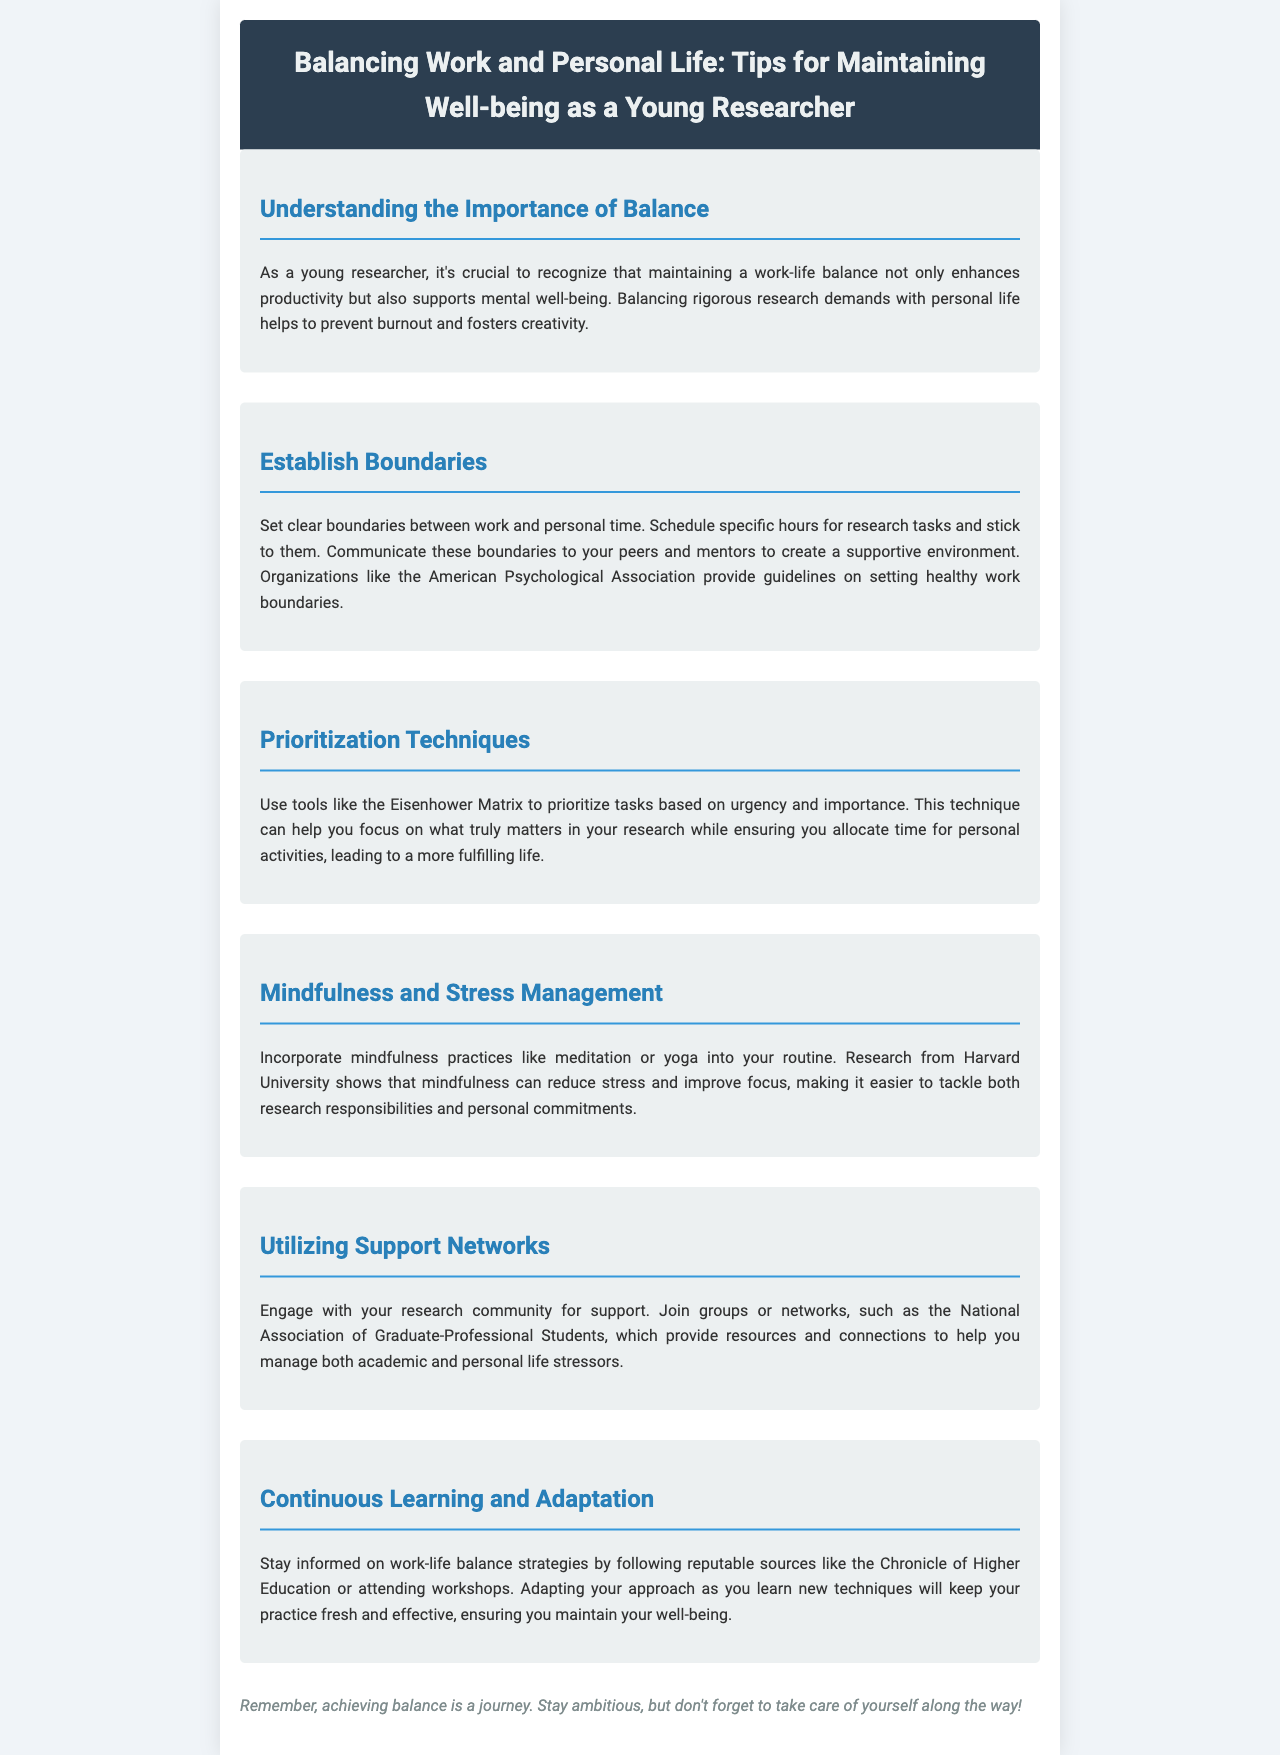What is the title of the newsletter? The title of the newsletter is stated at the top of the document.
Answer: Balancing Work and Personal Life: Tips for Maintaining Well-being as a Young Researcher What organization offers guidelines on setting healthy work boundaries? The document mentions an organization that provides guidelines for healthy work boundaries.
Answer: American Psychological Association What technique can help prioritize tasks? The document describes a tool that helps prioritize tasks based on urgency and importance.
Answer: Eisenhower Matrix Which university's research supports the benefits of mindfulness? The document references a specific university supporting mindfulness practices.
Answer: Harvard University What is the main theme of the section titled "Understanding the Importance of Balance"? The section discusses the significance of a specific concept for young researchers.
Answer: Work-life balance What type of practices are suggested for stress management? The document recommends specific practices aimed at reducing stress.
Answer: Mindfulness practices Which association is mentioned for engaging with the research community? The document refers to a specific association that provides resources for young researchers.
Answer: National Association of Graduate-Professional Students What type of document is this newsletter categorized as? The document provides guidance and tips for a specific group.
Answer: Newsletter 